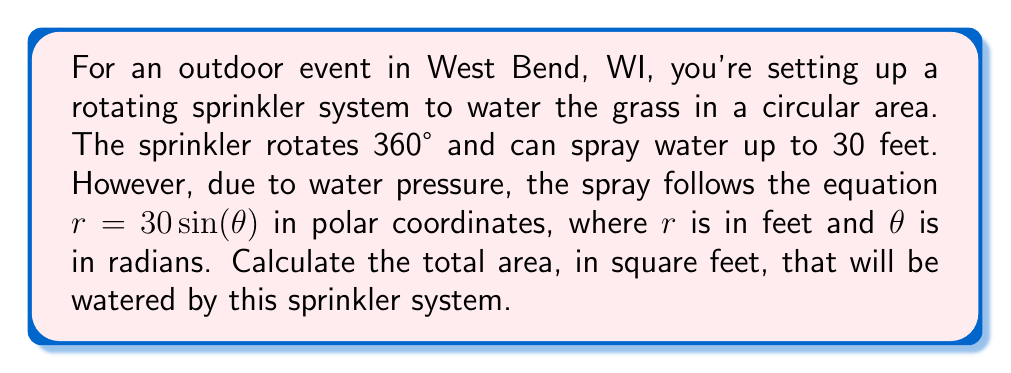Give your solution to this math problem. To solve this problem, we need to use the formula for the area of a region in polar coordinates:

$$A = \frac{1}{2}\int_{0}^{2\pi} r^2 d\theta$$

Given information:
- The equation of the spray is $r = 30\sin(\theta)$
- The sprinkler rotates a full 360°, so we integrate from 0 to $2\pi$

Steps:
1) Substitute the given equation into the area formula:
   $$A = \frac{1}{2}\int_{0}^{2\pi} (30\sin(\theta))^2 d\theta$$

2) Simplify the integrand:
   $$A = \frac{1}{2}\int_{0}^{2\pi} 900\sin^2(\theta) d\theta$$

3) Use the trigonometric identity $\sin^2(\theta) = \frac{1 - \cos(2\theta)}{2}$:
   $$A = \frac{1}{2}\int_{0}^{2\pi} 900 \cdot \frac{1 - \cos(2\theta)}{2} d\theta$$
   $$A = \frac{450}{2}\int_{0}^{2\pi} (1 - \cos(2\theta)) d\theta$$

4) Integrate:
   $$A = 225 \left[\theta - \frac{1}{2}\sin(2\theta)\right]_{0}^{2\pi}$$

5) Evaluate the integral:
   $$A = 225 \left[(2\pi - 0) - (\frac{1}{2}\sin(4\pi) - \frac{1}{2}\sin(0))\right]$$
   $$A = 225 \cdot 2\pi$$
   $$A = 450\pi$$

Therefore, the total area watered by the sprinkler system is $450\pi$ square feet.
Answer: $450\pi$ square feet 